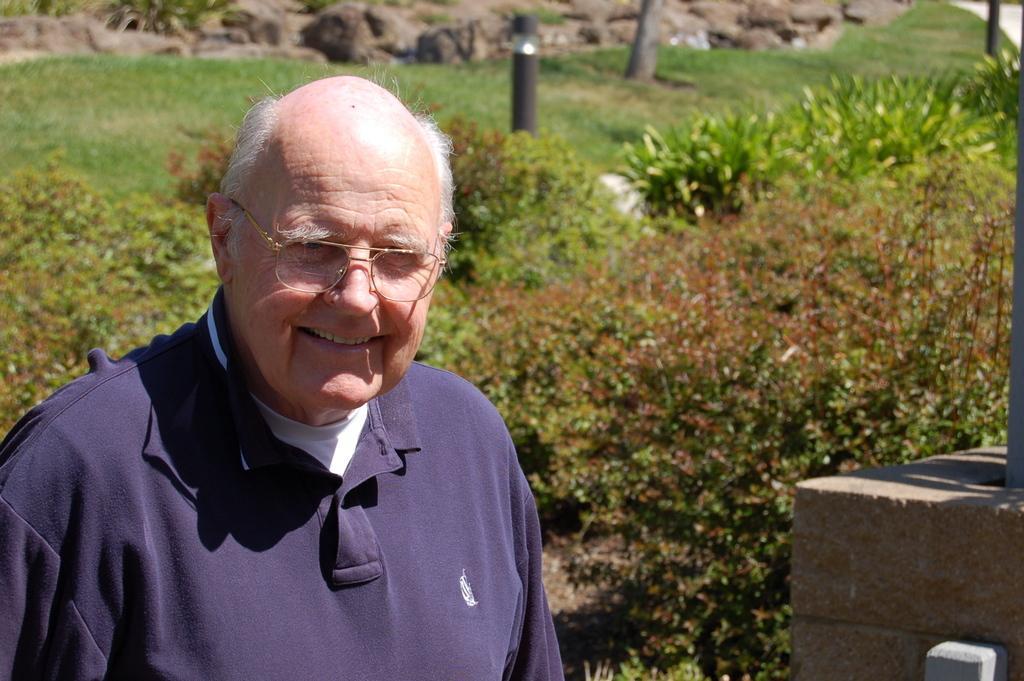Please provide a concise description of this image. In this image there is an old man wearing blue shirt. There is grass. There are plants and trees. There are mountains and stones in the background. On the right side there is an object. 